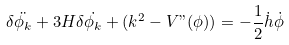<formula> <loc_0><loc_0><loc_500><loc_500>\delta \ddot { \phi _ { k } } + 3 H \delta \dot { \phi _ { k } } + ( k ^ { 2 } - V " ( \phi ) ) = - \frac { 1 } { 2 } \dot { h } \dot { \phi }</formula> 